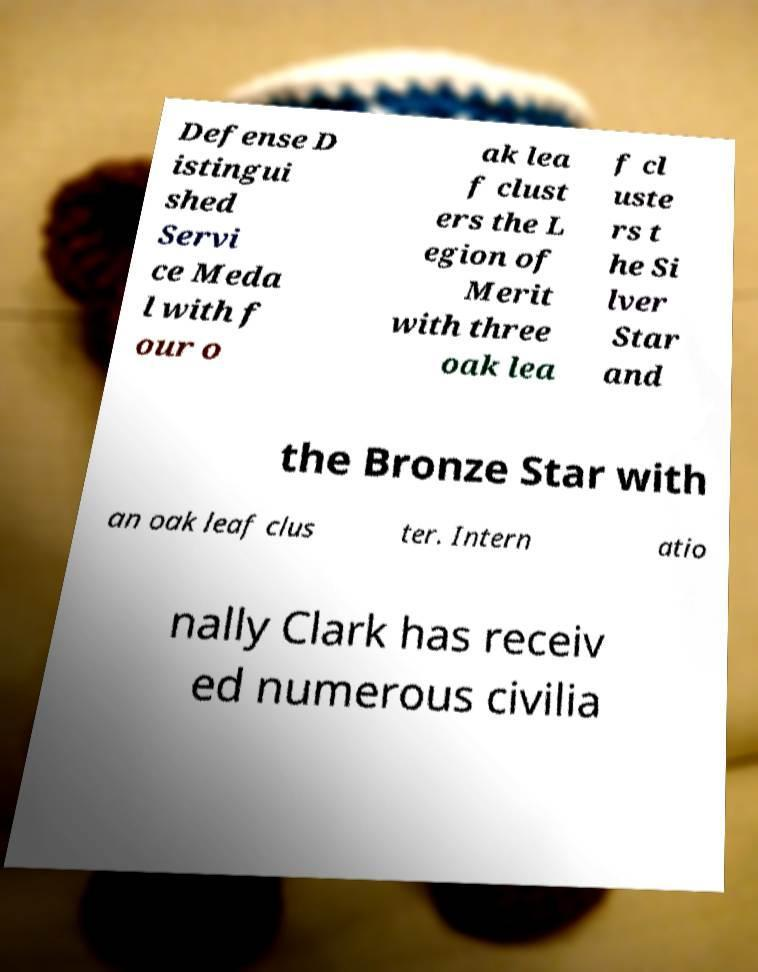Could you assist in decoding the text presented in this image and type it out clearly? Defense D istingui shed Servi ce Meda l with f our o ak lea f clust ers the L egion of Merit with three oak lea f cl uste rs t he Si lver Star and the Bronze Star with an oak leaf clus ter. Intern atio nally Clark has receiv ed numerous civilia 